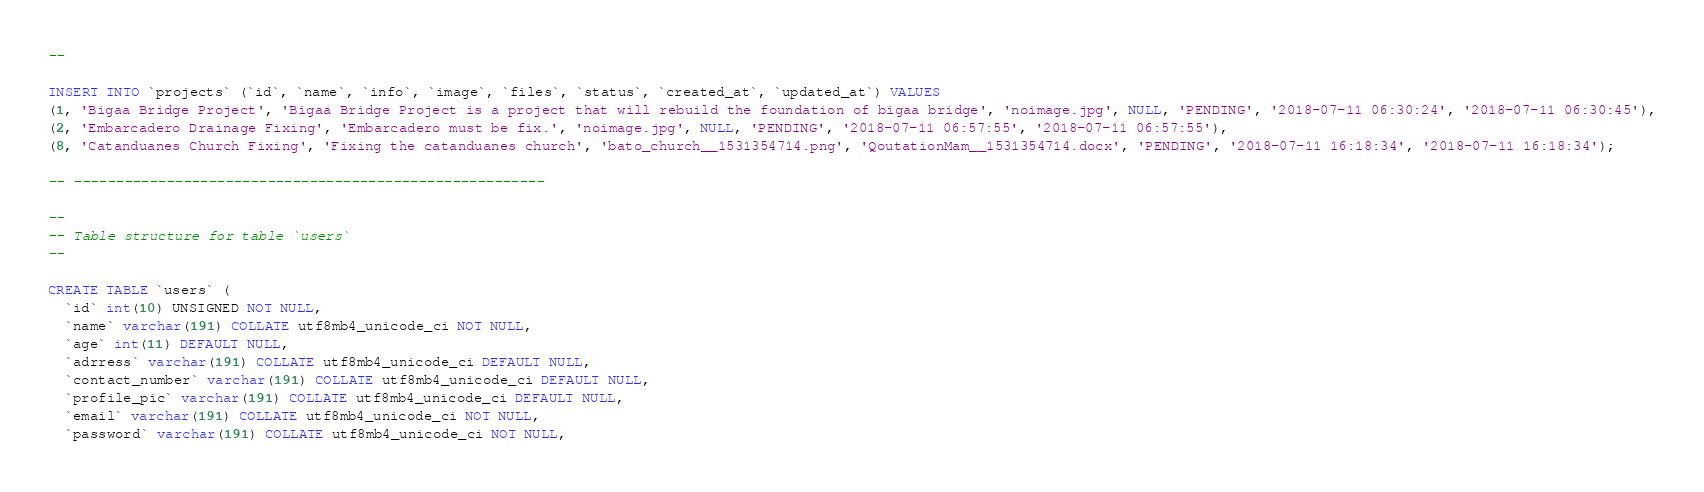Convert code to text. <code><loc_0><loc_0><loc_500><loc_500><_SQL_>--

INSERT INTO `projects` (`id`, `name`, `info`, `image`, `files`, `status`, `created_at`, `updated_at`) VALUES
(1, 'Bigaa Bridge Project', 'Bigaa Bridge Project is a project that will rebuild the foundation of bigaa bridge', 'noimage.jpg', NULL, 'PENDING', '2018-07-11 06:30:24', '2018-07-11 06:30:45'),
(2, 'Embarcadero Drainage Fixing', 'Embarcadero must be fix.', 'noimage.jpg', NULL, 'PENDING', '2018-07-11 06:57:55', '2018-07-11 06:57:55'),
(8, 'Catanduanes Church Fixing', 'Fixing the catanduanes church', 'bato_church__1531354714.png', 'QoutationMam__1531354714.docx', 'PENDING', '2018-07-11 16:18:34', '2018-07-11 16:18:34');

-- --------------------------------------------------------

--
-- Table structure for table `users`
--

CREATE TABLE `users` (
  `id` int(10) UNSIGNED NOT NULL,
  `name` varchar(191) COLLATE utf8mb4_unicode_ci NOT NULL,
  `age` int(11) DEFAULT NULL,
  `adrress` varchar(191) COLLATE utf8mb4_unicode_ci DEFAULT NULL,
  `contact_number` varchar(191) COLLATE utf8mb4_unicode_ci DEFAULT NULL,
  `profile_pic` varchar(191) COLLATE utf8mb4_unicode_ci DEFAULT NULL,
  `email` varchar(191) COLLATE utf8mb4_unicode_ci NOT NULL,
  `password` varchar(191) COLLATE utf8mb4_unicode_ci NOT NULL,</code> 